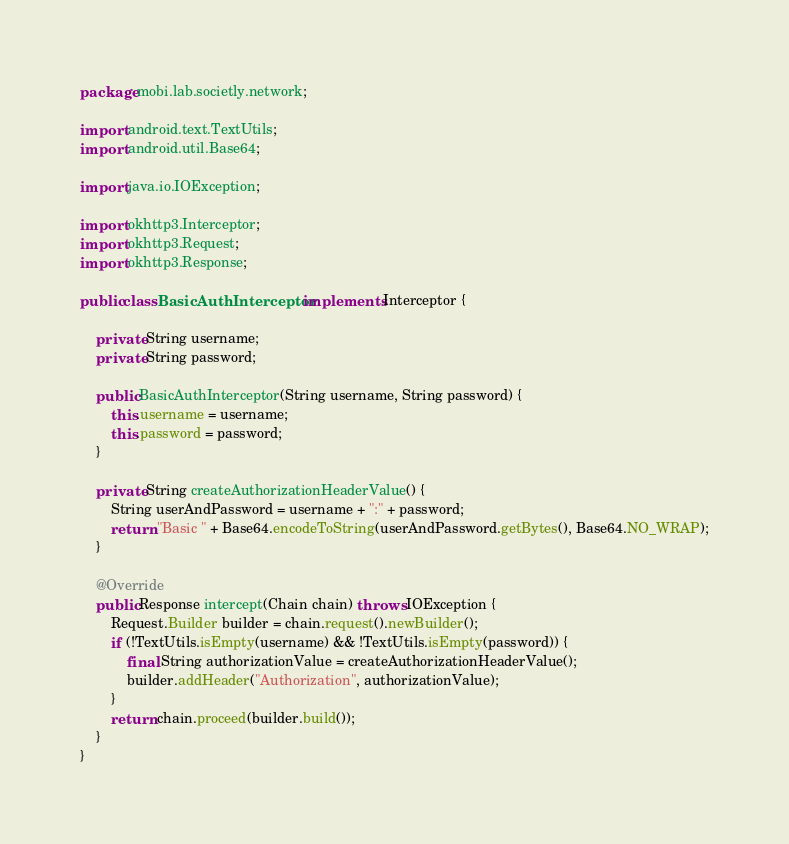<code> <loc_0><loc_0><loc_500><loc_500><_Java_>package mobi.lab.societly.network;

import android.text.TextUtils;
import android.util.Base64;

import java.io.IOException;

import okhttp3.Interceptor;
import okhttp3.Request;
import okhttp3.Response;

public class BasicAuthInterceptor implements Interceptor {

    private String username;
    private String password;

    public BasicAuthInterceptor(String username, String password) {
        this.username = username;
        this.password = password;
    }

    private String createAuthorizationHeaderValue() {
        String userAndPassword = username + ":" + password;
        return "Basic " + Base64.encodeToString(userAndPassword.getBytes(), Base64.NO_WRAP);
    }

    @Override
    public Response intercept(Chain chain) throws IOException {
        Request.Builder builder = chain.request().newBuilder();
        if (!TextUtils.isEmpty(username) && !TextUtils.isEmpty(password)) {
            final String authorizationValue = createAuthorizationHeaderValue();
            builder.addHeader("Authorization", authorizationValue);
        }
        return chain.proceed(builder.build());
    }
}
</code> 